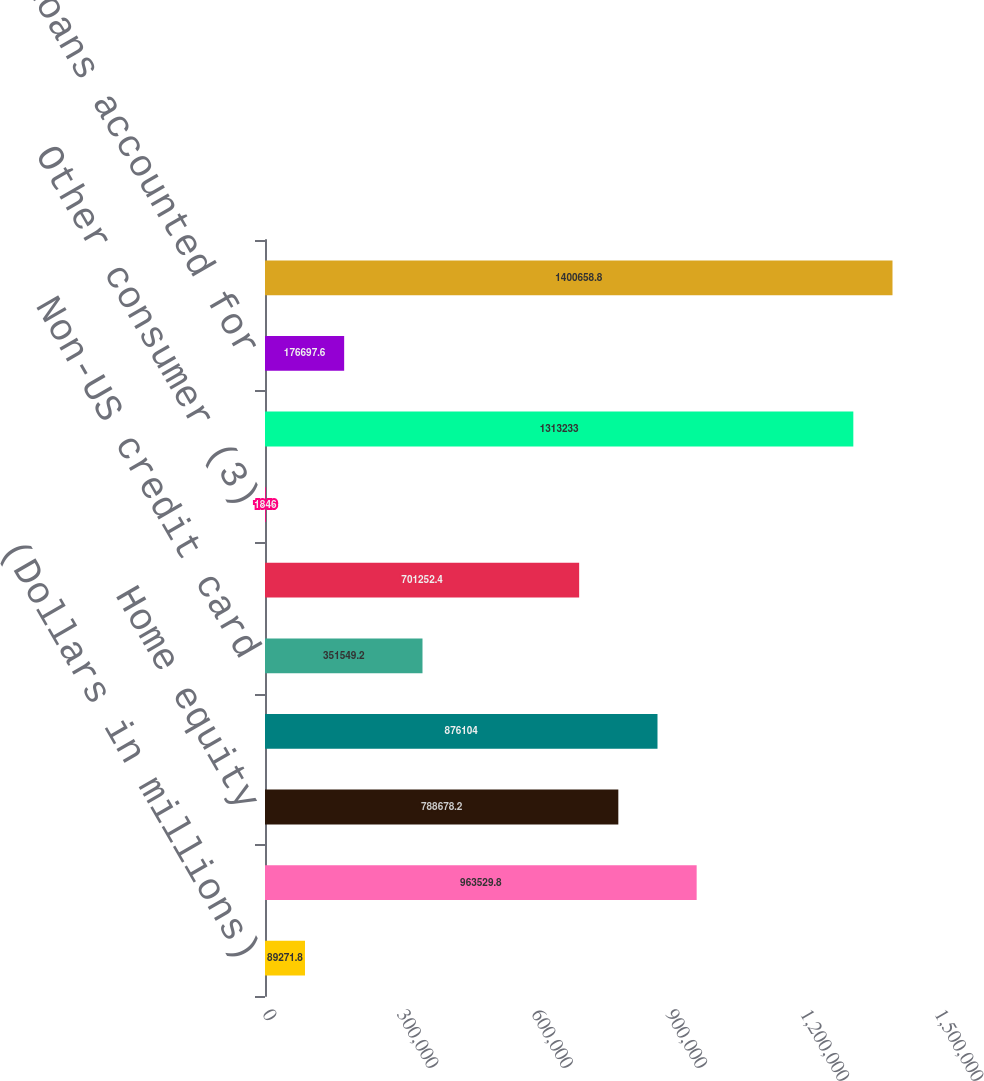Convert chart to OTSL. <chart><loc_0><loc_0><loc_500><loc_500><bar_chart><fcel>(Dollars in millions)<fcel>Residential mortgage (1)<fcel>Home equity<fcel>US credit card<fcel>Non-US credit card<fcel>Direct/Indirect consumer (2)<fcel>Other consumer (3)<fcel>Total consumer loans excluding<fcel>Consumer loans accounted for<fcel>Total consumer<nl><fcel>89271.8<fcel>963530<fcel>788678<fcel>876104<fcel>351549<fcel>701252<fcel>1846<fcel>1.31323e+06<fcel>176698<fcel>1.40066e+06<nl></chart> 